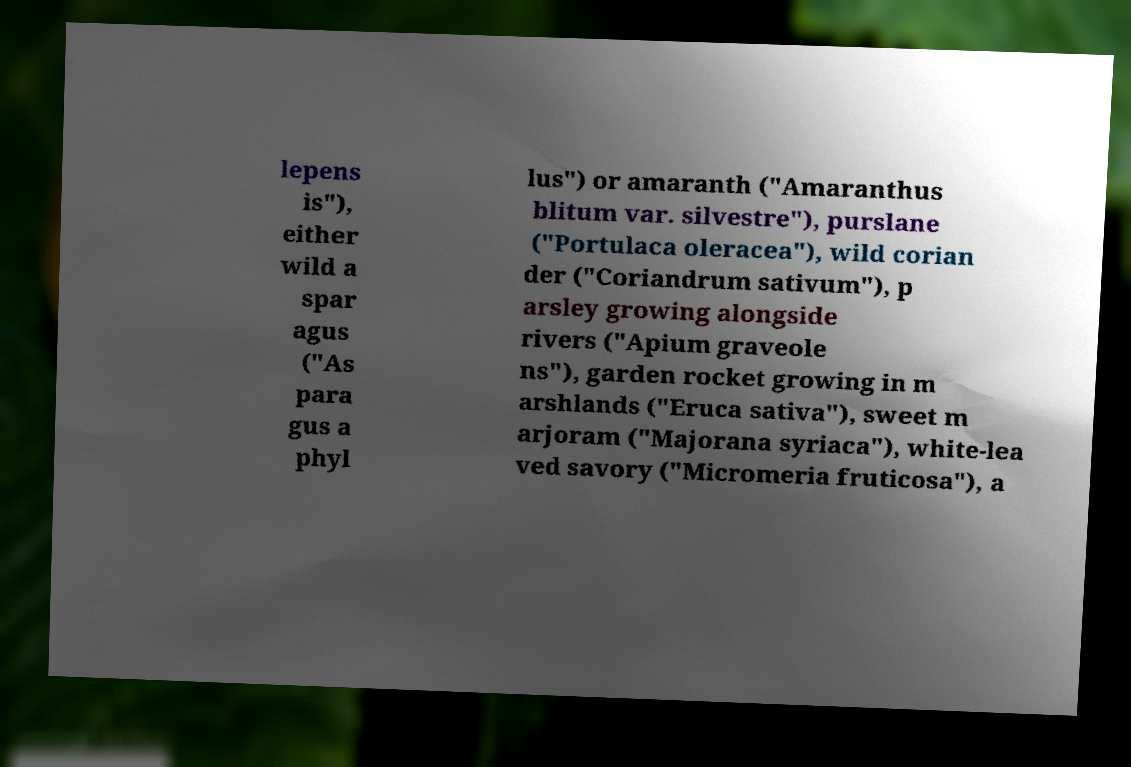Can you read and provide the text displayed in the image?This photo seems to have some interesting text. Can you extract and type it out for me? lepens is"), either wild a spar agus ("As para gus a phyl lus") or amaranth ("Amaranthus blitum var. silvestre"), purslane ("Portulaca oleracea"), wild corian der ("Coriandrum sativum"), p arsley growing alongside rivers ("Apium graveole ns"), garden rocket growing in m arshlands ("Eruca sativa"), sweet m arjoram ("Majorana syriaca"), white-lea ved savory ("Micromeria fruticosa"), a 